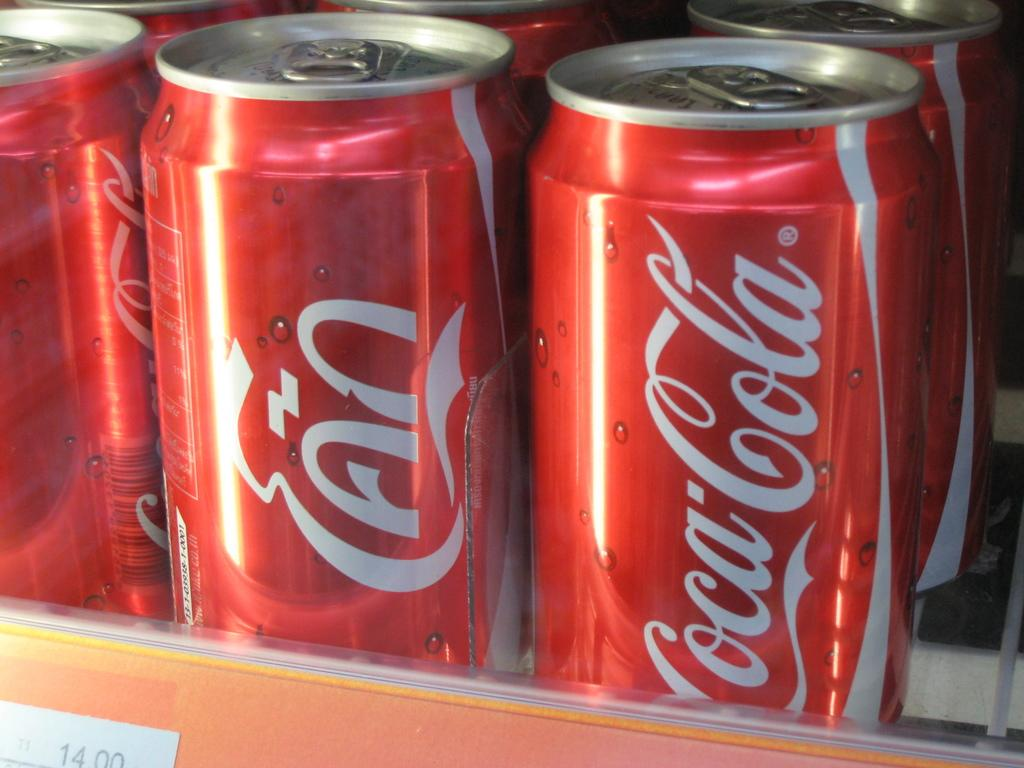<image>
Share a concise interpretation of the image provided. Several cans of coke are displayed in a cooler. 